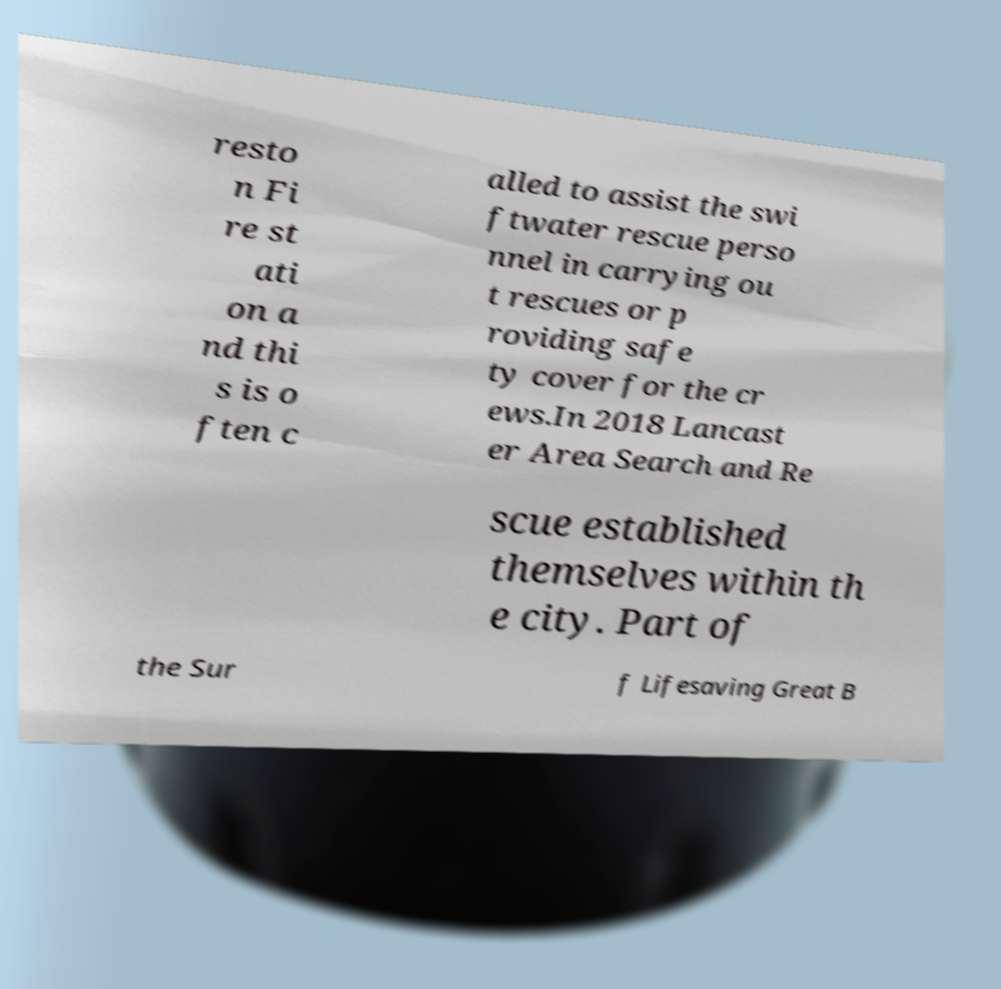Please read and relay the text visible in this image. What does it say? resto n Fi re st ati on a nd thi s is o ften c alled to assist the swi ftwater rescue perso nnel in carrying ou t rescues or p roviding safe ty cover for the cr ews.In 2018 Lancast er Area Search and Re scue established themselves within th e city. Part of the Sur f Lifesaving Great B 